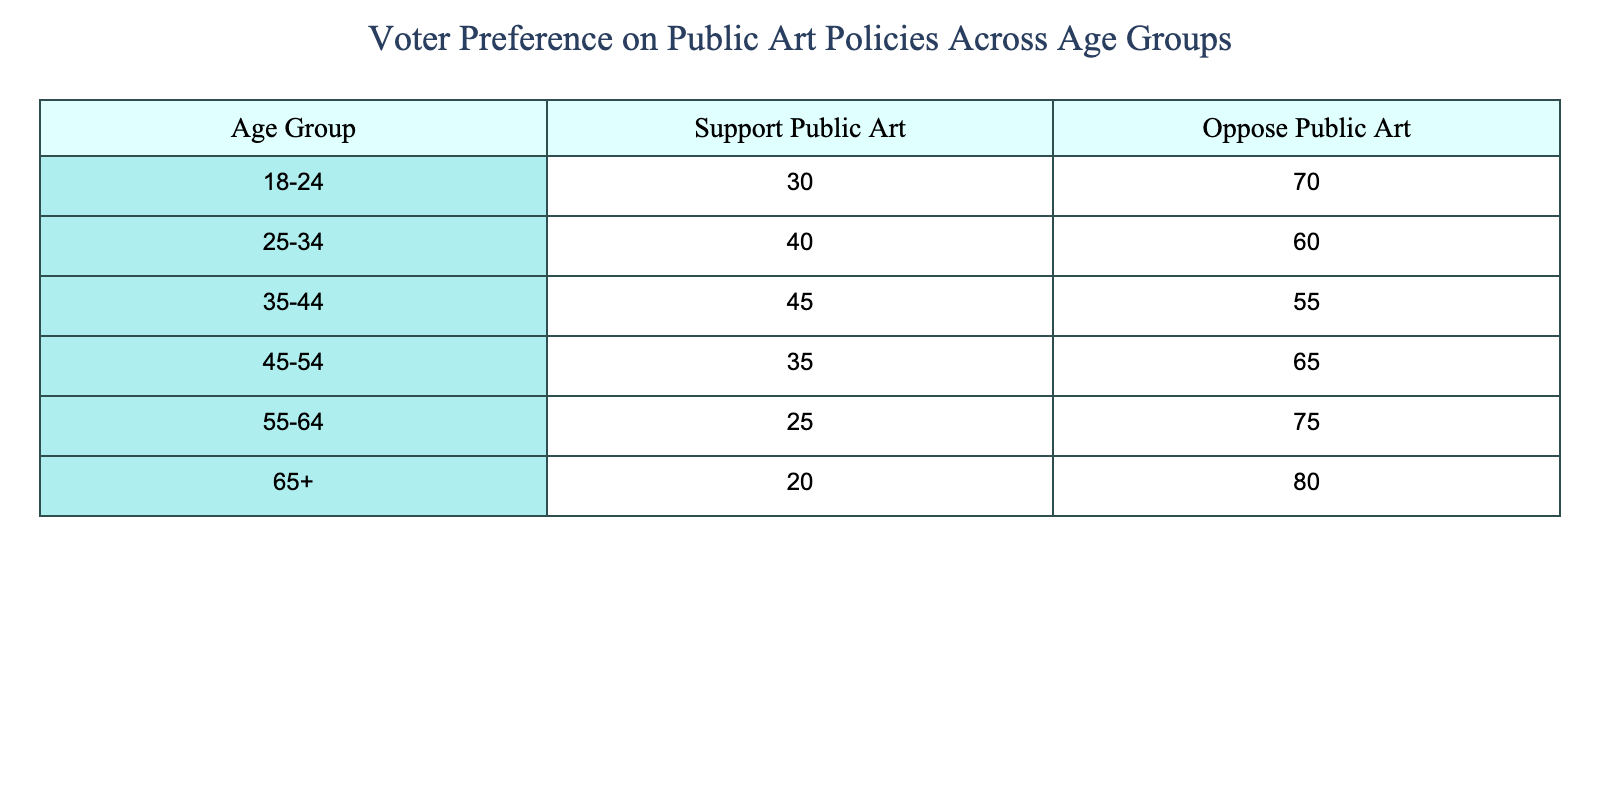What age group has the highest percentage opposing public art? By looking at the 'Oppose Public Art' column, the age group 65+ has the highest percentage at 80%.
Answer: 65+ What is the percentage of support for public art in the 35-44 age group? The value in the 'Support Public Art' column for the 35-44 age group is 45%.
Answer: 45% True or False: The percentage of individuals opposing public art is higher in the 55-64 age group compared to the 25-34 age group. The opposition percentage for the 55-64 age group is 75%, while for 25-34 it is 60%. Since 75% is greater than 60%, the statement is true.
Answer: True What is the difference in the percentage of support for public art between the 18-24 and 45-54 age groups? The support percentage for 18-24 is 30%, and for 45-54 it is 35%. The difference is 35 - 30 = 5%.
Answer: 5% What is the total percentage of people aged 55 and above who support public art? The support percentages for the groups 55-64 and 65+ are 25% and 20%, respectively. Adding these gives 25 + 20 = 45%.
Answer: 45% What age group has the lowest support for public art? Looking at the 'Support Public Art' column, the 65+ age group has the lowest percentage at 20%.
Answer: 65+ True or False: Older age groups (55 and above) have more opposition to public art than support. The opposition percentages for age groups 55-64 and 65+ are 75% and 80% respectively, both of which are greater than their corresponding support values, confirming the statement is true.
Answer: True What is the average support for public art across all age groups? Calculating the average: (30 + 40 + 45 + 35 + 25 + 20) = 195. There are 6 age groups, so the average is 195/6 ≈ 32.5%.
Answer: 32.5% 